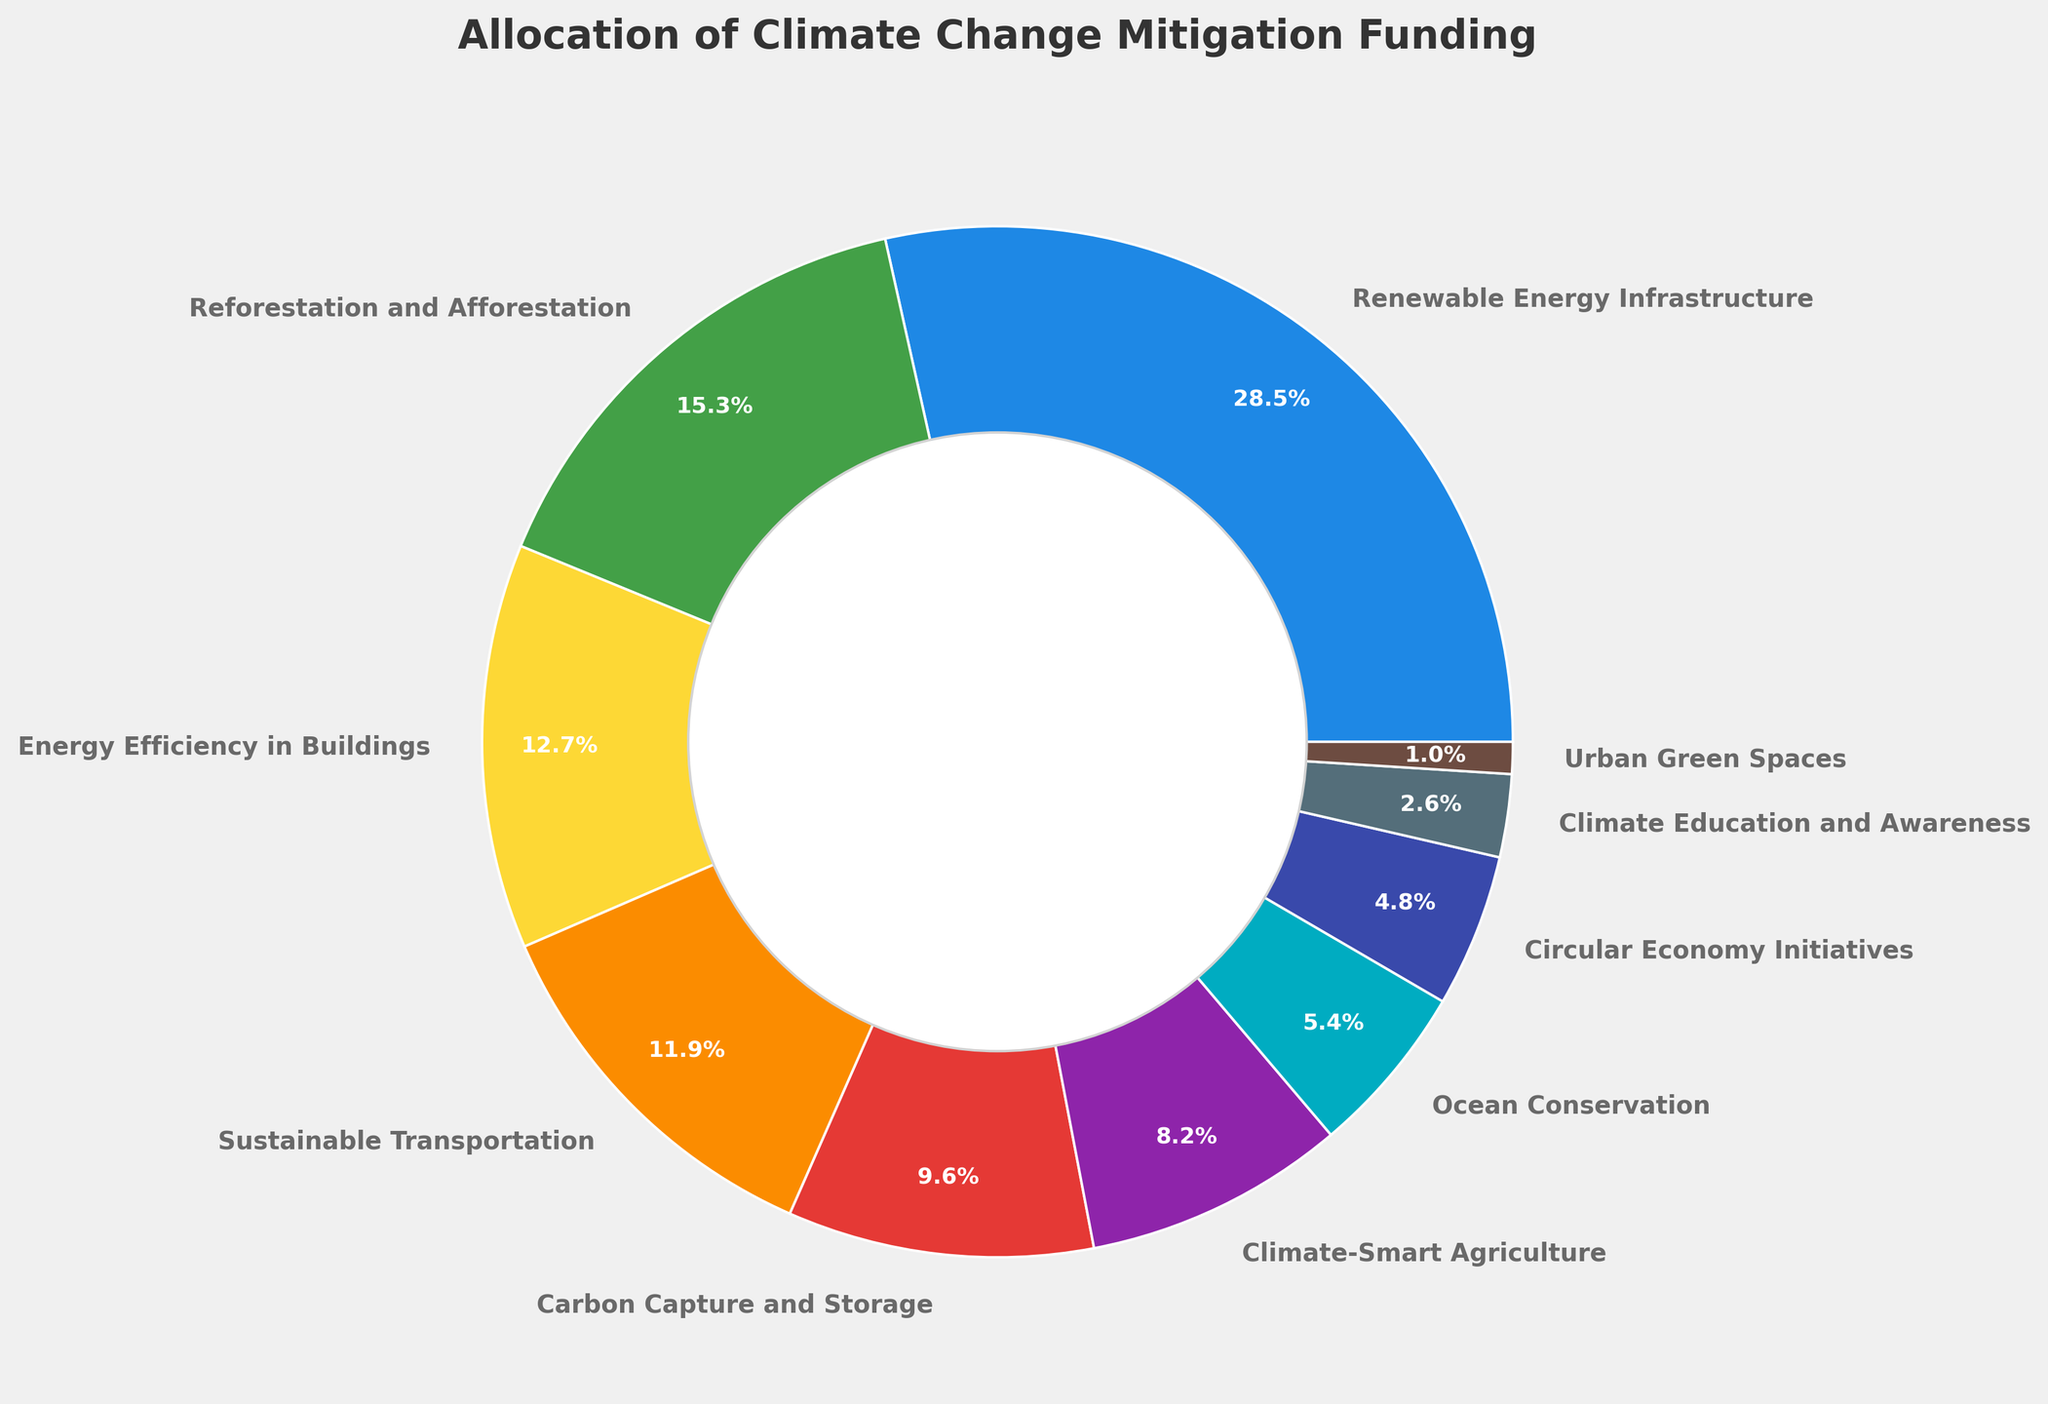What's the largest allocation of funding in the pie chart? The largest allocation of funding corresponds to the largest wedge in the pie chart. By examining the visual size of the wedges, the "Renewable Energy Infrastructure" section is the largest.
Answer: Renewable Energy Infrastructure Which funding strategy has the smallest allocation? The smallest allocation of funding corresponds to the smallest wedge in the pie chart. By comparing the wedges, the "Urban Green Spaces" section is the smallest.
Answer: Urban Green Spaces What is the combined funding percentage for Energy Efficiency in Buildings and Sustainable Transportation? To find the combined funding percentage, add the percentages of "Energy Efficiency in Buildings" (12.7%) and "Sustainable Transportation" (11.9%). The sum is 12.7% + 11.9% = 24.6%.
Answer: 24.6% Which strategy allocates more funding: Carbon Capture and Storage or Climate-Smart Agriculture? Compare the percentages of "Carbon Capture and Storage" (9.6%) and "Climate-Smart Agriculture" (8.2%). Since 9.6% is greater than 8.2%, "Carbon Capture and Storage" allocates more funding.
Answer: Carbon Capture and Storage How much more funding is allocated to Reforestation and Afforestation compared to Ocean Conservation? To find out how much more funding is allocated to Reforestation and Afforestation, subtract the percentage of Ocean Conservation (5.4%) from Reforestation and Afforestation (15.3%). The difference is 15.3% - 5.4% = 9.9%.
Answer: 9.9% What is the total funding percentage for strategies focused on natural ecosystems (Reforestation and Afforestation, Climate-Smart Agriculture, Ocean Conservation, Urban Green Spaces)? To find the total funding percentage for these strategies, sum their individual percentages: Reforestation and Afforestation (15.3%), Climate-Smart Agriculture (8.2%), Ocean Conservation (5.4%), and Urban Green Spaces (1.0%). The total is 15.3% + 8.2% + 5.4% + 1.0% = 29.9%.
Answer: 29.9% How does the funding allocation for Circular Economy Initiatives compare to Climate Education and Awareness? Compare the percentages of "Circular Economy Initiatives" (4.8%) and "Climate Education and Awareness" (2.6%). Since 4.8% is greater than 2.6%, Circular Economy Initiatives has a higher funding allocation.
Answer: Circular Economy Initiatives Which color represents Sustainable Transportation in the pie chart? By observing the colors in the pie chart and matching them to the legend or labels, "Sustainable Transportation" is represented in orange.
Answer: Orange What percentage of the total funding is allocated to Renewable Energy Infrastructure and Carbon Capture and Storage combined? To find the combined funding percentage, add the percentages of "Renewable Energy Infrastructure" (28.5%) and "Carbon Capture and Storage" (9.6%). The sum is 28.5% + 9.6% = 38.1%.
Answer: 38.1% 